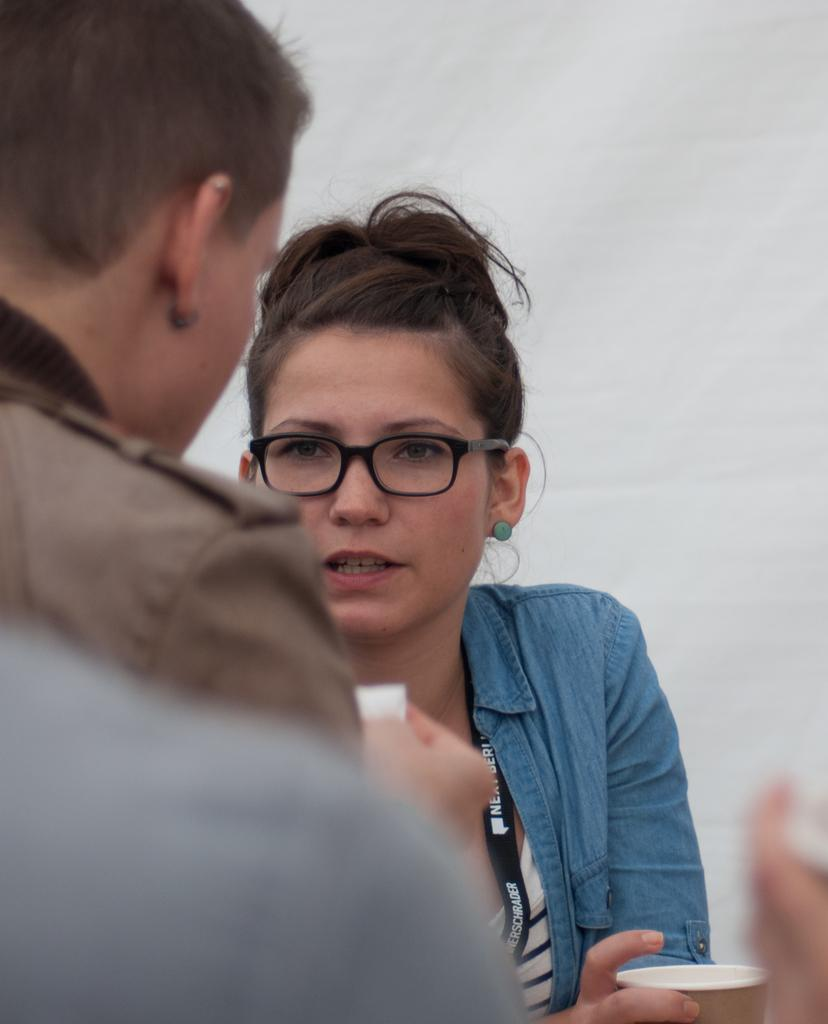Who is present in the image? There is a woman in the image. What is the woman wearing? The woman is wearing spectacles. What is the woman holding in the image? The woman is holding a cup. How many people are in the image? There are two people in the image. What type of lipstick is the woman wearing in the image? The woman is not wearing lipstick in the image; she is wearing spectacles. How many spiders are crawling on the woman in the image? There are no spiders present in the image; it only features a woman and a cup. 